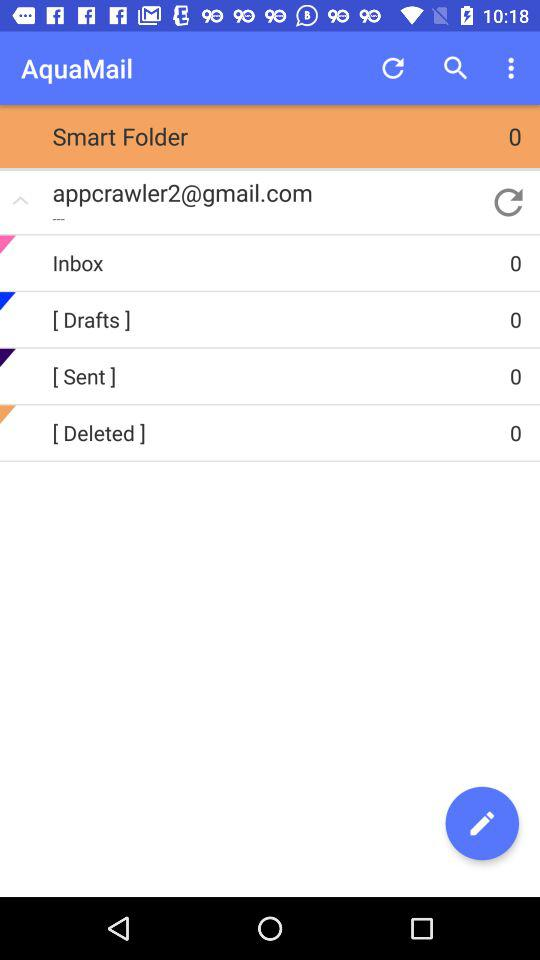How many items have the text '[Deleted]'?
Answer the question using a single word or phrase. 1 